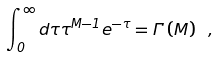Convert formula to latex. <formula><loc_0><loc_0><loc_500><loc_500>\int ^ { \infty } _ { 0 } d \tau \tau ^ { M - 1 } e ^ { - \tau } = \Gamma \left ( M \right ) \ ,</formula> 